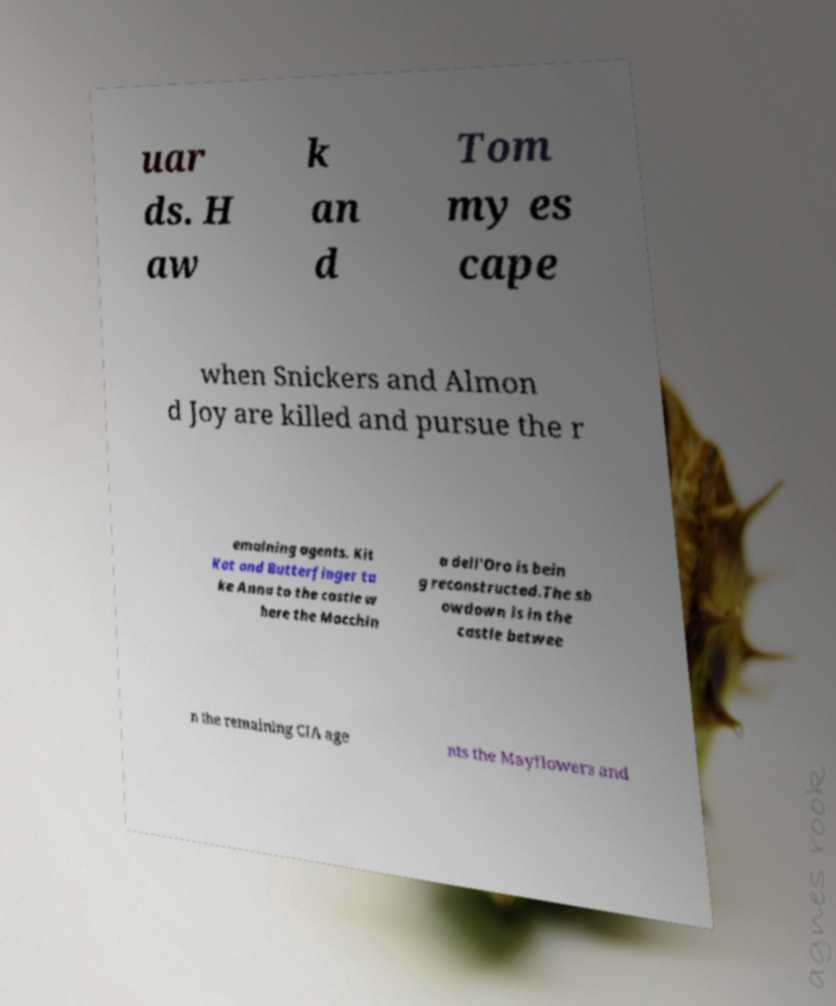Can you read and provide the text displayed in the image?This photo seems to have some interesting text. Can you extract and type it out for me? uar ds. H aw k an d Tom my es cape when Snickers and Almon d Joy are killed and pursue the r emaining agents. Kit Kat and Butterfinger ta ke Anna to the castle w here the Macchin a dell'Oro is bein g reconstructed.The sh owdown is in the castle betwee n the remaining CIA age nts the Mayflowers and 